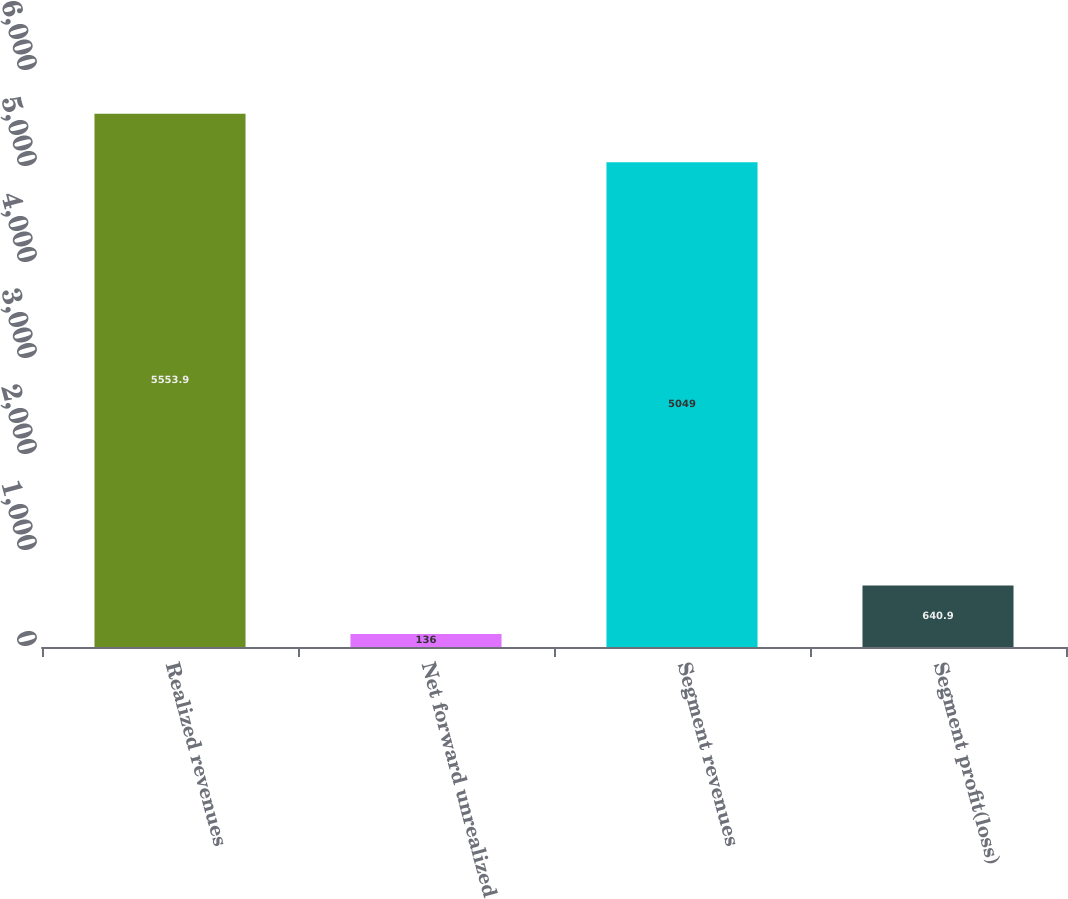Convert chart to OTSL. <chart><loc_0><loc_0><loc_500><loc_500><bar_chart><fcel>Realized revenues<fcel>Net forward unrealized<fcel>Segment revenues<fcel>Segment profit(loss)<nl><fcel>5553.9<fcel>136<fcel>5049<fcel>640.9<nl></chart> 